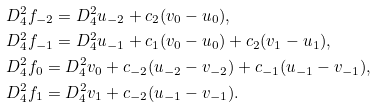Convert formula to latex. <formula><loc_0><loc_0><loc_500><loc_500>& D _ { 4 } ^ { 2 } f _ { - 2 } = D _ { 4 } ^ { 2 } u _ { - 2 } + c _ { 2 } ( v _ { 0 } - u _ { 0 } ) , \\ & D _ { 4 } ^ { 2 } f _ { - 1 } = D _ { 4 } ^ { 2 } u _ { - 1 } + c _ { 1 } ( v _ { 0 } - u _ { 0 } ) + c _ { 2 } ( v _ { 1 } - u _ { 1 } ) , \\ & D _ { 4 } ^ { 2 } f _ { 0 } = D _ { 4 } ^ { 2 } v _ { 0 } + c _ { - 2 } ( u _ { - 2 } - v _ { - 2 } ) + c _ { - 1 } ( u _ { - 1 } - v _ { - 1 } ) , \\ & D _ { 4 } ^ { 2 } f _ { 1 } = D _ { 4 } ^ { 2 } v _ { 1 } + c _ { - 2 } ( u _ { - 1 } - v _ { - 1 } ) .</formula> 